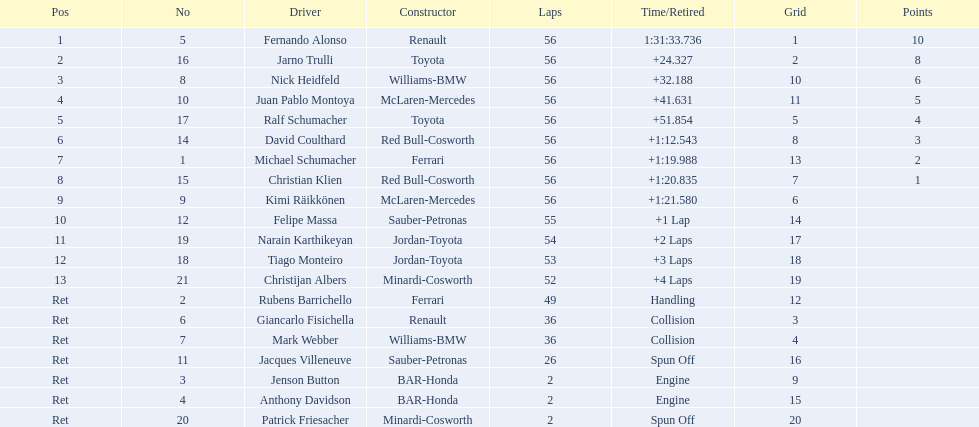Who served as fernando alonso's coach? Renault. What was the total number of laps completed by fernando alonso? 56. What was the duration of the race for alonso? 1:31:33.736. 